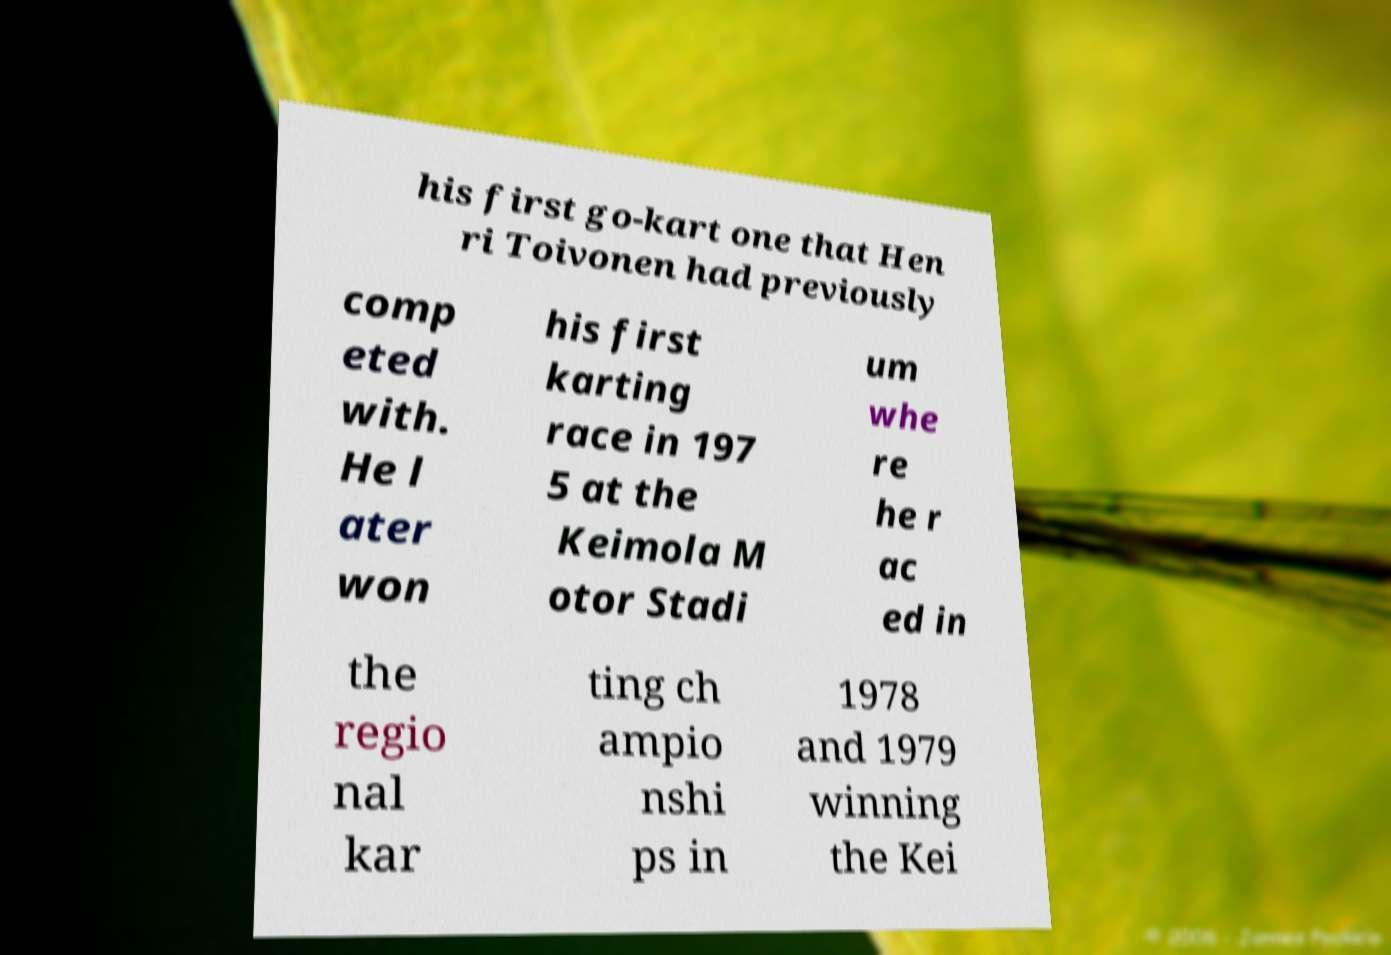What messages or text are displayed in this image? I need them in a readable, typed format. his first go-kart one that Hen ri Toivonen had previously comp eted with. He l ater won his first karting race in 197 5 at the Keimola M otor Stadi um whe re he r ac ed in the regio nal kar ting ch ampio nshi ps in 1978 and 1979 winning the Kei 